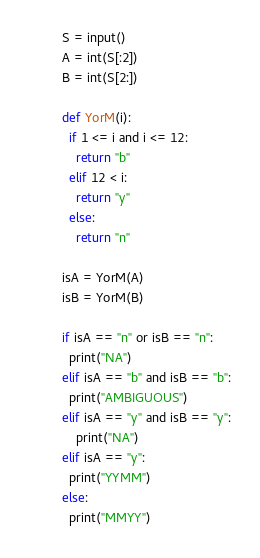<code> <loc_0><loc_0><loc_500><loc_500><_Python_>S = input()
A = int(S[:2])
B = int(S[2:])

def YorM(i):
  if 1 <= i and i <= 12:
    return "b"
  elif 12 < i:
    return "y"
  else:
    return "n"
  
isA = YorM(A)
isB = YorM(B)

if isA == "n" or isB == "n":
  print("NA")
elif isA == "b" and isB == "b":
  print("AMBIGUOUS")
elif isA == "y" and isB == "y":
    print("NA")
elif isA == "y":
  print("YYMM")
else:
  print("MMYY")</code> 